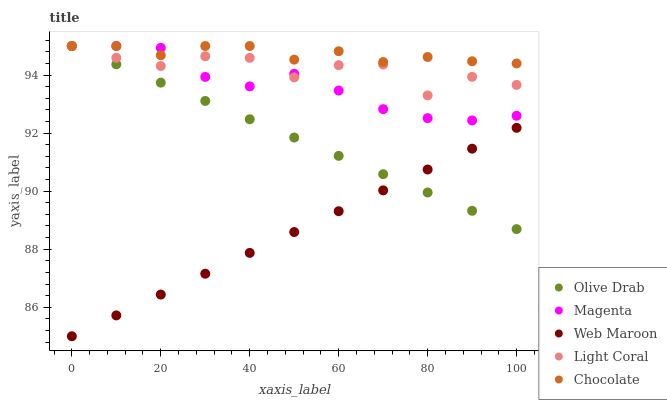Does Web Maroon have the minimum area under the curve?
Answer yes or no. Yes. Does Chocolate have the maximum area under the curve?
Answer yes or no. Yes. Does Magenta have the minimum area under the curve?
Answer yes or no. No. Does Magenta have the maximum area under the curve?
Answer yes or no. No. Is Web Maroon the smoothest?
Answer yes or no. Yes. Is Light Coral the roughest?
Answer yes or no. Yes. Is Magenta the smoothest?
Answer yes or no. No. Is Magenta the roughest?
Answer yes or no. No. Does Web Maroon have the lowest value?
Answer yes or no. Yes. Does Magenta have the lowest value?
Answer yes or no. No. Does Chocolate have the highest value?
Answer yes or no. Yes. Does Web Maroon have the highest value?
Answer yes or no. No. Is Web Maroon less than Chocolate?
Answer yes or no. Yes. Is Light Coral greater than Web Maroon?
Answer yes or no. Yes. Does Chocolate intersect Light Coral?
Answer yes or no. Yes. Is Chocolate less than Light Coral?
Answer yes or no. No. Is Chocolate greater than Light Coral?
Answer yes or no. No. Does Web Maroon intersect Chocolate?
Answer yes or no. No. 